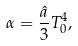Convert formula to latex. <formula><loc_0><loc_0><loc_500><loc_500>\alpha = \frac { \hat { a } } { 3 } T _ { 0 } ^ { 4 } ,</formula> 